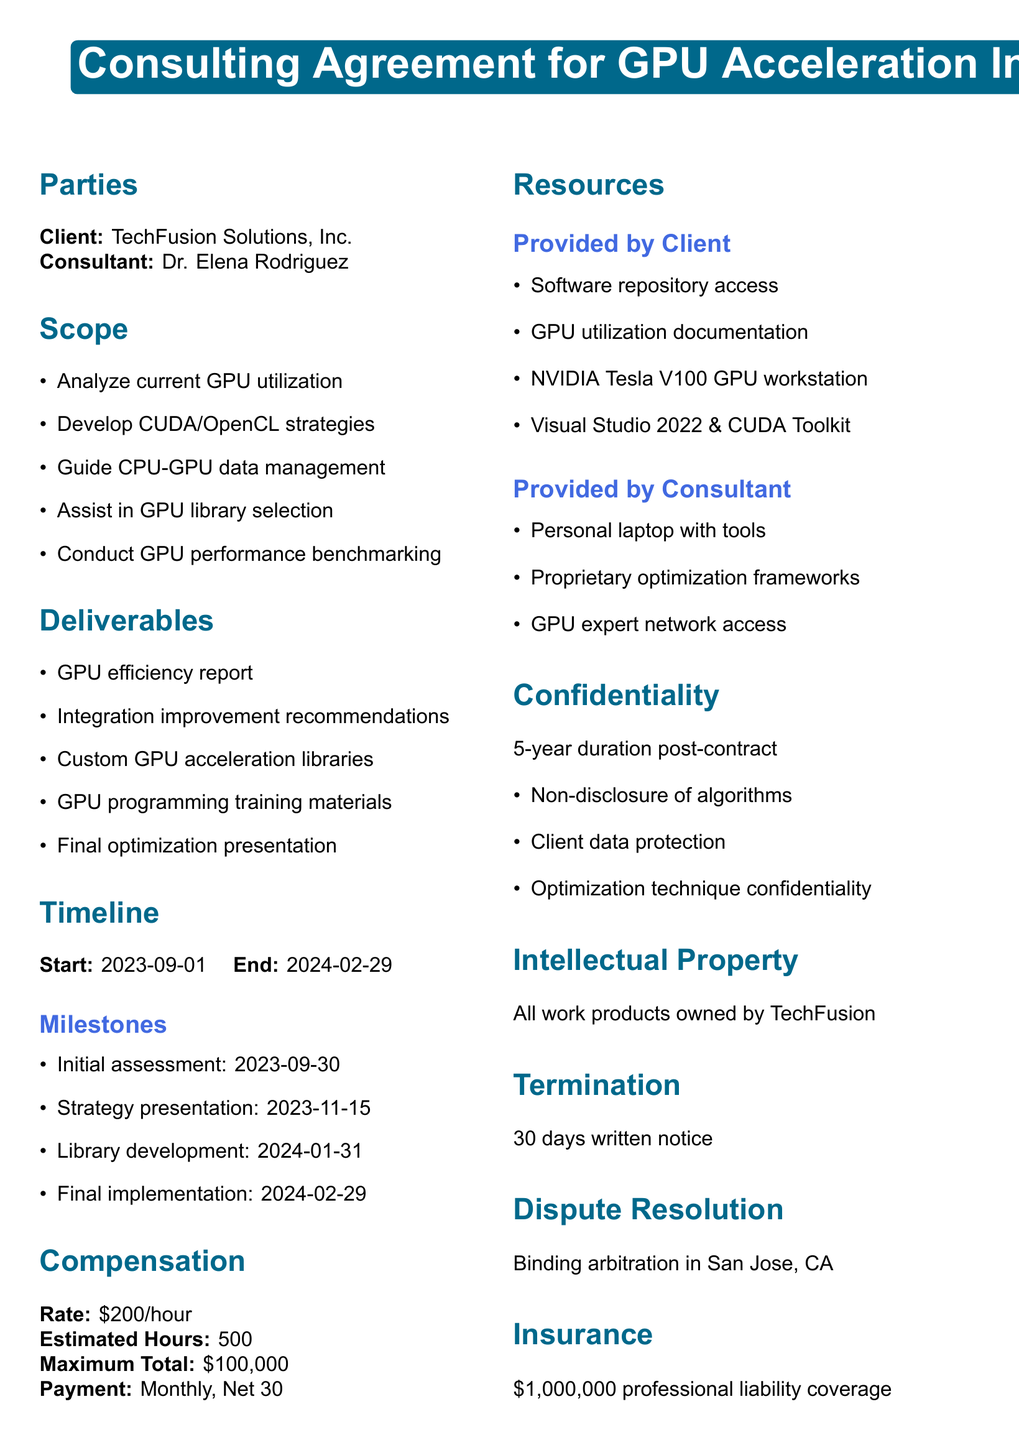What is the contract title? The contract title is explicitly stated at the beginning of the document, indicating the nature of the agreement.
Answer: Consulting Agreement for GPU Acceleration Integration Who is the consultant? The name of the consultant is clearly listed under the parties section of the document.
Answer: Dr. Elena Rodriguez, GPU Integration Specialist What is the maximum total compensation? The maximum total compensation is specified under the compensation section of the document.
Answer: $100,000 When does the contract start? The start date is mentioned in the timeline section of the document.
Answer: 2023-09-01 What is the payment schedule? The information regarding the payment schedule is provided in the compensation section.
Answer: Monthly invoicing with net 30 terms What are the deliverables? The deliverables are listed as items that the consultant must provide as outcomes of the engagement.
Answer: Comprehensive report on current GPU utilization efficiency How long is the confidentiality duration? The duration for confidentiality is specified in the confidentiality section of the document.
Answer: 5 years from the end of the contract What is the governing law for dispute resolution? The governing law is mentioned in the dispute resolution section.
Answer: Laws of the State of California What document type is this? The overall purpose and nature of the document indicate it is a specific type of legal agreement.
Answer: Consulting Agreement 